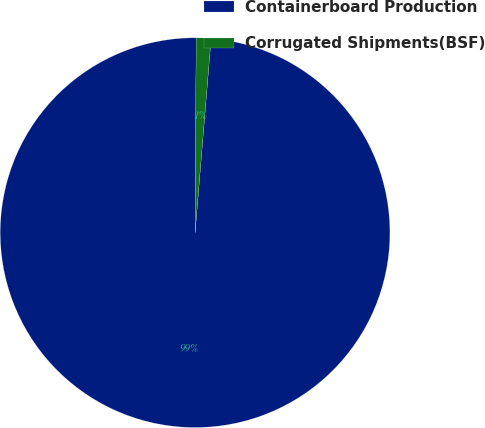<chart> <loc_0><loc_0><loc_500><loc_500><pie_chart><fcel>Containerboard Production<fcel>Corrugated Shipments(BSF)<nl><fcel>98.78%<fcel>1.22%<nl></chart> 